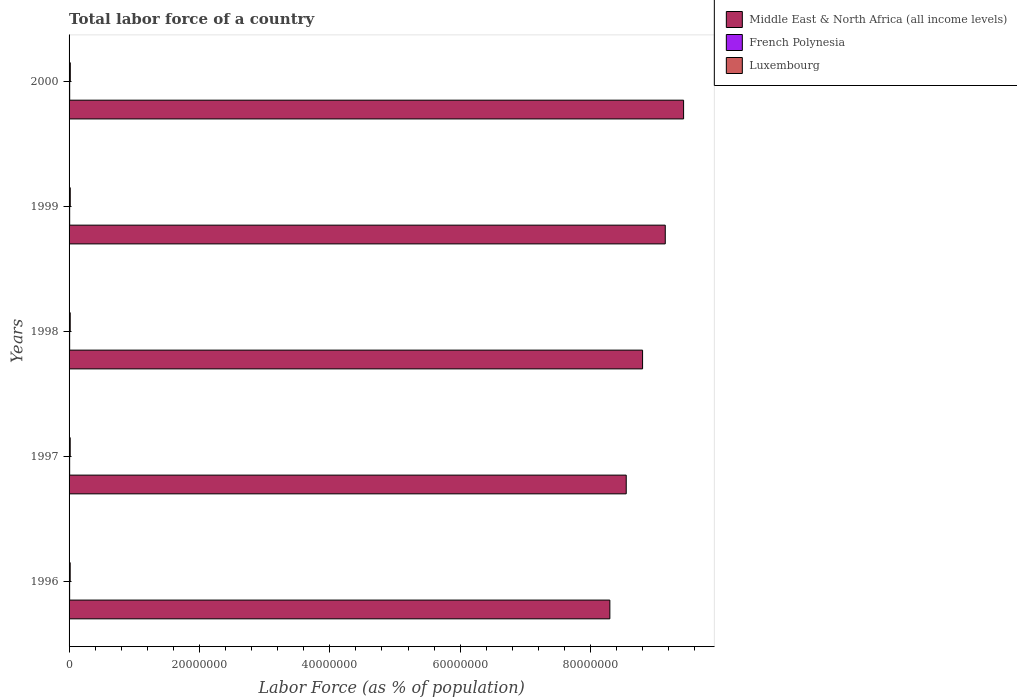How many groups of bars are there?
Your answer should be very brief. 5. How many bars are there on the 1st tick from the bottom?
Offer a very short reply. 3. What is the percentage of labor force in French Polynesia in 2000?
Ensure brevity in your answer.  9.52e+04. Across all years, what is the maximum percentage of labor force in Luxembourg?
Keep it short and to the point. 1.89e+05. Across all years, what is the minimum percentage of labor force in Middle East & North Africa (all income levels)?
Provide a short and direct response. 8.30e+07. In which year was the percentage of labor force in French Polynesia minimum?
Your answer should be compact. 1996. What is the total percentage of labor force in French Polynesia in the graph?
Give a very brief answer. 4.54e+05. What is the difference between the percentage of labor force in Middle East & North Africa (all income levels) in 1997 and that in 1998?
Your response must be concise. -2.51e+06. What is the difference between the percentage of labor force in Luxembourg in 1996 and the percentage of labor force in French Polynesia in 1997?
Make the answer very short. 8.30e+04. What is the average percentage of labor force in French Polynesia per year?
Ensure brevity in your answer.  9.08e+04. In the year 1996, what is the difference between the percentage of labor force in French Polynesia and percentage of labor force in Middle East & North Africa (all income levels)?
Provide a succinct answer. -8.29e+07. In how many years, is the percentage of labor force in French Polynesia greater than 48000000 %?
Give a very brief answer. 0. What is the ratio of the percentage of labor force in Middle East & North Africa (all income levels) in 1997 to that in 1998?
Offer a terse response. 0.97. Is the percentage of labor force in Middle East & North Africa (all income levels) in 1998 less than that in 1999?
Keep it short and to the point. Yes. Is the difference between the percentage of labor force in French Polynesia in 1996 and 1998 greater than the difference between the percentage of labor force in Middle East & North Africa (all income levels) in 1996 and 1998?
Your response must be concise. Yes. What is the difference between the highest and the second highest percentage of labor force in Middle East & North Africa (all income levels)?
Your answer should be very brief. 2.81e+06. What is the difference between the highest and the lowest percentage of labor force in Middle East & North Africa (all income levels)?
Offer a terse response. 1.13e+07. What does the 3rd bar from the top in 2000 represents?
Offer a very short reply. Middle East & North Africa (all income levels). What does the 2nd bar from the bottom in 1998 represents?
Ensure brevity in your answer.  French Polynesia. Is it the case that in every year, the sum of the percentage of labor force in Middle East & North Africa (all income levels) and percentage of labor force in Luxembourg is greater than the percentage of labor force in French Polynesia?
Keep it short and to the point. Yes. How many bars are there?
Offer a terse response. 15. Are all the bars in the graph horizontal?
Provide a succinct answer. Yes. How many years are there in the graph?
Your answer should be compact. 5. What is the difference between two consecutive major ticks on the X-axis?
Give a very brief answer. 2.00e+07. How are the legend labels stacked?
Give a very brief answer. Vertical. What is the title of the graph?
Provide a short and direct response. Total labor force of a country. Does "Pacific island small states" appear as one of the legend labels in the graph?
Offer a very short reply. No. What is the label or title of the X-axis?
Offer a terse response. Labor Force (as % of population). What is the label or title of the Y-axis?
Your response must be concise. Years. What is the Labor Force (as % of population) of Middle East & North Africa (all income levels) in 1996?
Give a very brief answer. 8.30e+07. What is the Labor Force (as % of population) in French Polynesia in 1996?
Make the answer very short. 8.65e+04. What is the Labor Force (as % of population) of Luxembourg in 1996?
Give a very brief answer. 1.72e+05. What is the Labor Force (as % of population) of Middle East & North Africa (all income levels) in 1997?
Your answer should be very brief. 8.55e+07. What is the Labor Force (as % of population) in French Polynesia in 1997?
Keep it short and to the point. 8.86e+04. What is the Labor Force (as % of population) in Luxembourg in 1997?
Give a very brief answer. 1.74e+05. What is the Labor Force (as % of population) of Middle East & North Africa (all income levels) in 1998?
Make the answer very short. 8.80e+07. What is the Labor Force (as % of population) in French Polynesia in 1998?
Your response must be concise. 9.08e+04. What is the Labor Force (as % of population) of Luxembourg in 1998?
Offer a terse response. 1.77e+05. What is the Labor Force (as % of population) in Middle East & North Africa (all income levels) in 1999?
Your response must be concise. 9.15e+07. What is the Labor Force (as % of population) of French Polynesia in 1999?
Make the answer very short. 9.30e+04. What is the Labor Force (as % of population) in Luxembourg in 1999?
Your answer should be compact. 1.82e+05. What is the Labor Force (as % of population) of Middle East & North Africa (all income levels) in 2000?
Provide a short and direct response. 9.43e+07. What is the Labor Force (as % of population) in French Polynesia in 2000?
Provide a short and direct response. 9.52e+04. What is the Labor Force (as % of population) of Luxembourg in 2000?
Keep it short and to the point. 1.89e+05. Across all years, what is the maximum Labor Force (as % of population) in Middle East & North Africa (all income levels)?
Your answer should be very brief. 9.43e+07. Across all years, what is the maximum Labor Force (as % of population) of French Polynesia?
Your response must be concise. 9.52e+04. Across all years, what is the maximum Labor Force (as % of population) of Luxembourg?
Your answer should be very brief. 1.89e+05. Across all years, what is the minimum Labor Force (as % of population) in Middle East & North Africa (all income levels)?
Your answer should be very brief. 8.30e+07. Across all years, what is the minimum Labor Force (as % of population) of French Polynesia?
Keep it short and to the point. 8.65e+04. Across all years, what is the minimum Labor Force (as % of population) in Luxembourg?
Provide a short and direct response. 1.72e+05. What is the total Labor Force (as % of population) of Middle East & North Africa (all income levels) in the graph?
Your answer should be very brief. 4.42e+08. What is the total Labor Force (as % of population) of French Polynesia in the graph?
Keep it short and to the point. 4.54e+05. What is the total Labor Force (as % of population) of Luxembourg in the graph?
Your answer should be compact. 8.93e+05. What is the difference between the Labor Force (as % of population) in Middle East & North Africa (all income levels) in 1996 and that in 1997?
Your answer should be compact. -2.51e+06. What is the difference between the Labor Force (as % of population) of French Polynesia in 1996 and that in 1997?
Make the answer very short. -2146. What is the difference between the Labor Force (as % of population) in Luxembourg in 1996 and that in 1997?
Make the answer very short. -2569. What is the difference between the Labor Force (as % of population) of Middle East & North Africa (all income levels) in 1996 and that in 1998?
Give a very brief answer. -5.02e+06. What is the difference between the Labor Force (as % of population) of French Polynesia in 1996 and that in 1998?
Offer a terse response. -4340. What is the difference between the Labor Force (as % of population) of Luxembourg in 1996 and that in 1998?
Offer a terse response. -5248. What is the difference between the Labor Force (as % of population) in Middle East & North Africa (all income levels) in 1996 and that in 1999?
Offer a terse response. -8.50e+06. What is the difference between the Labor Force (as % of population) in French Polynesia in 1996 and that in 1999?
Your answer should be compact. -6544. What is the difference between the Labor Force (as % of population) in Luxembourg in 1996 and that in 1999?
Your answer should be very brief. -1.03e+04. What is the difference between the Labor Force (as % of population) in Middle East & North Africa (all income levels) in 1996 and that in 2000?
Your answer should be very brief. -1.13e+07. What is the difference between the Labor Force (as % of population) of French Polynesia in 1996 and that in 2000?
Provide a short and direct response. -8751. What is the difference between the Labor Force (as % of population) in Luxembourg in 1996 and that in 2000?
Offer a terse response. -1.73e+04. What is the difference between the Labor Force (as % of population) in Middle East & North Africa (all income levels) in 1997 and that in 1998?
Provide a succinct answer. -2.51e+06. What is the difference between the Labor Force (as % of population) in French Polynesia in 1997 and that in 1998?
Offer a terse response. -2194. What is the difference between the Labor Force (as % of population) in Luxembourg in 1997 and that in 1998?
Your answer should be very brief. -2679. What is the difference between the Labor Force (as % of population) in Middle East & North Africa (all income levels) in 1997 and that in 1999?
Give a very brief answer. -5.99e+06. What is the difference between the Labor Force (as % of population) of French Polynesia in 1997 and that in 1999?
Provide a short and direct response. -4398. What is the difference between the Labor Force (as % of population) in Luxembourg in 1997 and that in 1999?
Your answer should be compact. -7735. What is the difference between the Labor Force (as % of population) of Middle East & North Africa (all income levels) in 1997 and that in 2000?
Provide a short and direct response. -8.80e+06. What is the difference between the Labor Force (as % of population) in French Polynesia in 1997 and that in 2000?
Provide a succinct answer. -6605. What is the difference between the Labor Force (as % of population) of Luxembourg in 1997 and that in 2000?
Give a very brief answer. -1.47e+04. What is the difference between the Labor Force (as % of population) in Middle East & North Africa (all income levels) in 1998 and that in 1999?
Make the answer very short. -3.48e+06. What is the difference between the Labor Force (as % of population) of French Polynesia in 1998 and that in 1999?
Make the answer very short. -2204. What is the difference between the Labor Force (as % of population) in Luxembourg in 1998 and that in 1999?
Offer a very short reply. -5056. What is the difference between the Labor Force (as % of population) of Middle East & North Africa (all income levels) in 1998 and that in 2000?
Give a very brief answer. -6.29e+06. What is the difference between the Labor Force (as % of population) of French Polynesia in 1998 and that in 2000?
Offer a terse response. -4411. What is the difference between the Labor Force (as % of population) of Luxembourg in 1998 and that in 2000?
Ensure brevity in your answer.  -1.20e+04. What is the difference between the Labor Force (as % of population) of Middle East & North Africa (all income levels) in 1999 and that in 2000?
Your response must be concise. -2.81e+06. What is the difference between the Labor Force (as % of population) of French Polynesia in 1999 and that in 2000?
Give a very brief answer. -2207. What is the difference between the Labor Force (as % of population) of Luxembourg in 1999 and that in 2000?
Keep it short and to the point. -6961. What is the difference between the Labor Force (as % of population) in Middle East & North Africa (all income levels) in 1996 and the Labor Force (as % of population) in French Polynesia in 1997?
Offer a very short reply. 8.29e+07. What is the difference between the Labor Force (as % of population) in Middle East & North Africa (all income levels) in 1996 and the Labor Force (as % of population) in Luxembourg in 1997?
Your answer should be very brief. 8.28e+07. What is the difference between the Labor Force (as % of population) in French Polynesia in 1996 and the Labor Force (as % of population) in Luxembourg in 1997?
Make the answer very short. -8.77e+04. What is the difference between the Labor Force (as % of population) in Middle East & North Africa (all income levels) in 1996 and the Labor Force (as % of population) in French Polynesia in 1998?
Your response must be concise. 8.29e+07. What is the difference between the Labor Force (as % of population) of Middle East & North Africa (all income levels) in 1996 and the Labor Force (as % of population) of Luxembourg in 1998?
Your response must be concise. 8.28e+07. What is the difference between the Labor Force (as % of population) in French Polynesia in 1996 and the Labor Force (as % of population) in Luxembourg in 1998?
Provide a short and direct response. -9.04e+04. What is the difference between the Labor Force (as % of population) in Middle East & North Africa (all income levels) in 1996 and the Labor Force (as % of population) in French Polynesia in 1999?
Offer a very short reply. 8.29e+07. What is the difference between the Labor Force (as % of population) in Middle East & North Africa (all income levels) in 1996 and the Labor Force (as % of population) in Luxembourg in 1999?
Keep it short and to the point. 8.28e+07. What is the difference between the Labor Force (as % of population) in French Polynesia in 1996 and the Labor Force (as % of population) in Luxembourg in 1999?
Give a very brief answer. -9.54e+04. What is the difference between the Labor Force (as % of population) of Middle East & North Africa (all income levels) in 1996 and the Labor Force (as % of population) of French Polynesia in 2000?
Ensure brevity in your answer.  8.29e+07. What is the difference between the Labor Force (as % of population) of Middle East & North Africa (all income levels) in 1996 and the Labor Force (as % of population) of Luxembourg in 2000?
Offer a very short reply. 8.28e+07. What is the difference between the Labor Force (as % of population) of French Polynesia in 1996 and the Labor Force (as % of population) of Luxembourg in 2000?
Ensure brevity in your answer.  -1.02e+05. What is the difference between the Labor Force (as % of population) of Middle East & North Africa (all income levels) in 1997 and the Labor Force (as % of population) of French Polynesia in 1998?
Offer a terse response. 8.54e+07. What is the difference between the Labor Force (as % of population) of Middle East & North Africa (all income levels) in 1997 and the Labor Force (as % of population) of Luxembourg in 1998?
Provide a succinct answer. 8.53e+07. What is the difference between the Labor Force (as % of population) in French Polynesia in 1997 and the Labor Force (as % of population) in Luxembourg in 1998?
Make the answer very short. -8.82e+04. What is the difference between the Labor Force (as % of population) in Middle East & North Africa (all income levels) in 1997 and the Labor Force (as % of population) in French Polynesia in 1999?
Provide a short and direct response. 8.54e+07. What is the difference between the Labor Force (as % of population) of Middle East & North Africa (all income levels) in 1997 and the Labor Force (as % of population) of Luxembourg in 1999?
Your answer should be compact. 8.53e+07. What is the difference between the Labor Force (as % of population) of French Polynesia in 1997 and the Labor Force (as % of population) of Luxembourg in 1999?
Your response must be concise. -9.33e+04. What is the difference between the Labor Force (as % of population) in Middle East & North Africa (all income levels) in 1997 and the Labor Force (as % of population) in French Polynesia in 2000?
Offer a terse response. 8.54e+07. What is the difference between the Labor Force (as % of population) of Middle East & North Africa (all income levels) in 1997 and the Labor Force (as % of population) of Luxembourg in 2000?
Provide a succinct answer. 8.53e+07. What is the difference between the Labor Force (as % of population) in French Polynesia in 1997 and the Labor Force (as % of population) in Luxembourg in 2000?
Ensure brevity in your answer.  -1.00e+05. What is the difference between the Labor Force (as % of population) in Middle East & North Africa (all income levels) in 1998 and the Labor Force (as % of population) in French Polynesia in 1999?
Ensure brevity in your answer.  8.79e+07. What is the difference between the Labor Force (as % of population) in Middle East & North Africa (all income levels) in 1998 and the Labor Force (as % of population) in Luxembourg in 1999?
Offer a very short reply. 8.78e+07. What is the difference between the Labor Force (as % of population) of French Polynesia in 1998 and the Labor Force (as % of population) of Luxembourg in 1999?
Your response must be concise. -9.11e+04. What is the difference between the Labor Force (as % of population) of Middle East & North Africa (all income levels) in 1998 and the Labor Force (as % of population) of French Polynesia in 2000?
Your response must be concise. 8.79e+07. What is the difference between the Labor Force (as % of population) in Middle East & North Africa (all income levels) in 1998 and the Labor Force (as % of population) in Luxembourg in 2000?
Your response must be concise. 8.78e+07. What is the difference between the Labor Force (as % of population) in French Polynesia in 1998 and the Labor Force (as % of population) in Luxembourg in 2000?
Make the answer very short. -9.80e+04. What is the difference between the Labor Force (as % of population) of Middle East & North Africa (all income levels) in 1999 and the Labor Force (as % of population) of French Polynesia in 2000?
Ensure brevity in your answer.  9.14e+07. What is the difference between the Labor Force (as % of population) of Middle East & North Africa (all income levels) in 1999 and the Labor Force (as % of population) of Luxembourg in 2000?
Offer a terse response. 9.13e+07. What is the difference between the Labor Force (as % of population) in French Polynesia in 1999 and the Labor Force (as % of population) in Luxembourg in 2000?
Your answer should be very brief. -9.58e+04. What is the average Labor Force (as % of population) in Middle East & North Africa (all income levels) per year?
Offer a terse response. 8.84e+07. What is the average Labor Force (as % of population) in French Polynesia per year?
Make the answer very short. 9.08e+04. What is the average Labor Force (as % of population) of Luxembourg per year?
Your answer should be compact. 1.79e+05. In the year 1996, what is the difference between the Labor Force (as % of population) of Middle East & North Africa (all income levels) and Labor Force (as % of population) of French Polynesia?
Offer a very short reply. 8.29e+07. In the year 1996, what is the difference between the Labor Force (as % of population) in Middle East & North Africa (all income levels) and Labor Force (as % of population) in Luxembourg?
Make the answer very short. 8.28e+07. In the year 1996, what is the difference between the Labor Force (as % of population) of French Polynesia and Labor Force (as % of population) of Luxembourg?
Keep it short and to the point. -8.51e+04. In the year 1997, what is the difference between the Labor Force (as % of population) of Middle East & North Africa (all income levels) and Labor Force (as % of population) of French Polynesia?
Provide a succinct answer. 8.54e+07. In the year 1997, what is the difference between the Labor Force (as % of population) of Middle East & North Africa (all income levels) and Labor Force (as % of population) of Luxembourg?
Keep it short and to the point. 8.53e+07. In the year 1997, what is the difference between the Labor Force (as % of population) of French Polynesia and Labor Force (as % of population) of Luxembourg?
Offer a very short reply. -8.55e+04. In the year 1998, what is the difference between the Labor Force (as % of population) of Middle East & North Africa (all income levels) and Labor Force (as % of population) of French Polynesia?
Offer a very short reply. 8.79e+07. In the year 1998, what is the difference between the Labor Force (as % of population) of Middle East & North Africa (all income levels) and Labor Force (as % of population) of Luxembourg?
Give a very brief answer. 8.78e+07. In the year 1998, what is the difference between the Labor Force (as % of population) in French Polynesia and Labor Force (as % of population) in Luxembourg?
Provide a short and direct response. -8.60e+04. In the year 1999, what is the difference between the Labor Force (as % of population) of Middle East & North Africa (all income levels) and Labor Force (as % of population) of French Polynesia?
Offer a terse response. 9.14e+07. In the year 1999, what is the difference between the Labor Force (as % of population) of Middle East & North Africa (all income levels) and Labor Force (as % of population) of Luxembourg?
Ensure brevity in your answer.  9.13e+07. In the year 1999, what is the difference between the Labor Force (as % of population) in French Polynesia and Labor Force (as % of population) in Luxembourg?
Offer a terse response. -8.89e+04. In the year 2000, what is the difference between the Labor Force (as % of population) in Middle East & North Africa (all income levels) and Labor Force (as % of population) in French Polynesia?
Make the answer very short. 9.42e+07. In the year 2000, what is the difference between the Labor Force (as % of population) of Middle East & North Africa (all income levels) and Labor Force (as % of population) of Luxembourg?
Ensure brevity in your answer.  9.41e+07. In the year 2000, what is the difference between the Labor Force (as % of population) of French Polynesia and Labor Force (as % of population) of Luxembourg?
Your answer should be compact. -9.36e+04. What is the ratio of the Labor Force (as % of population) of Middle East & North Africa (all income levels) in 1996 to that in 1997?
Your answer should be compact. 0.97. What is the ratio of the Labor Force (as % of population) of French Polynesia in 1996 to that in 1997?
Your response must be concise. 0.98. What is the ratio of the Labor Force (as % of population) of Luxembourg in 1996 to that in 1997?
Offer a terse response. 0.99. What is the ratio of the Labor Force (as % of population) of Middle East & North Africa (all income levels) in 1996 to that in 1998?
Make the answer very short. 0.94. What is the ratio of the Labor Force (as % of population) of French Polynesia in 1996 to that in 1998?
Provide a short and direct response. 0.95. What is the ratio of the Labor Force (as % of population) of Luxembourg in 1996 to that in 1998?
Your answer should be compact. 0.97. What is the ratio of the Labor Force (as % of population) of Middle East & North Africa (all income levels) in 1996 to that in 1999?
Ensure brevity in your answer.  0.91. What is the ratio of the Labor Force (as % of population) in French Polynesia in 1996 to that in 1999?
Keep it short and to the point. 0.93. What is the ratio of the Labor Force (as % of population) of Luxembourg in 1996 to that in 1999?
Your answer should be compact. 0.94. What is the ratio of the Labor Force (as % of population) of Middle East & North Africa (all income levels) in 1996 to that in 2000?
Provide a succinct answer. 0.88. What is the ratio of the Labor Force (as % of population) of French Polynesia in 1996 to that in 2000?
Offer a terse response. 0.91. What is the ratio of the Labor Force (as % of population) of Luxembourg in 1996 to that in 2000?
Your answer should be very brief. 0.91. What is the ratio of the Labor Force (as % of population) in Middle East & North Africa (all income levels) in 1997 to that in 1998?
Offer a terse response. 0.97. What is the ratio of the Labor Force (as % of population) of French Polynesia in 1997 to that in 1998?
Offer a terse response. 0.98. What is the ratio of the Labor Force (as % of population) in Luxembourg in 1997 to that in 1998?
Your answer should be very brief. 0.98. What is the ratio of the Labor Force (as % of population) in Middle East & North Africa (all income levels) in 1997 to that in 1999?
Offer a very short reply. 0.93. What is the ratio of the Labor Force (as % of population) in French Polynesia in 1997 to that in 1999?
Ensure brevity in your answer.  0.95. What is the ratio of the Labor Force (as % of population) of Luxembourg in 1997 to that in 1999?
Offer a terse response. 0.96. What is the ratio of the Labor Force (as % of population) in Middle East & North Africa (all income levels) in 1997 to that in 2000?
Offer a terse response. 0.91. What is the ratio of the Labor Force (as % of population) of French Polynesia in 1997 to that in 2000?
Your response must be concise. 0.93. What is the ratio of the Labor Force (as % of population) of Luxembourg in 1997 to that in 2000?
Give a very brief answer. 0.92. What is the ratio of the Labor Force (as % of population) of French Polynesia in 1998 to that in 1999?
Your answer should be compact. 0.98. What is the ratio of the Labor Force (as % of population) of Luxembourg in 1998 to that in 1999?
Ensure brevity in your answer.  0.97. What is the ratio of the Labor Force (as % of population) in French Polynesia in 1998 to that in 2000?
Offer a very short reply. 0.95. What is the ratio of the Labor Force (as % of population) in Luxembourg in 1998 to that in 2000?
Offer a very short reply. 0.94. What is the ratio of the Labor Force (as % of population) in Middle East & North Africa (all income levels) in 1999 to that in 2000?
Keep it short and to the point. 0.97. What is the ratio of the Labor Force (as % of population) in French Polynesia in 1999 to that in 2000?
Your answer should be very brief. 0.98. What is the ratio of the Labor Force (as % of population) in Luxembourg in 1999 to that in 2000?
Offer a terse response. 0.96. What is the difference between the highest and the second highest Labor Force (as % of population) of Middle East & North Africa (all income levels)?
Ensure brevity in your answer.  2.81e+06. What is the difference between the highest and the second highest Labor Force (as % of population) of French Polynesia?
Make the answer very short. 2207. What is the difference between the highest and the second highest Labor Force (as % of population) in Luxembourg?
Your response must be concise. 6961. What is the difference between the highest and the lowest Labor Force (as % of population) of Middle East & North Africa (all income levels)?
Keep it short and to the point. 1.13e+07. What is the difference between the highest and the lowest Labor Force (as % of population) in French Polynesia?
Ensure brevity in your answer.  8751. What is the difference between the highest and the lowest Labor Force (as % of population) in Luxembourg?
Give a very brief answer. 1.73e+04. 